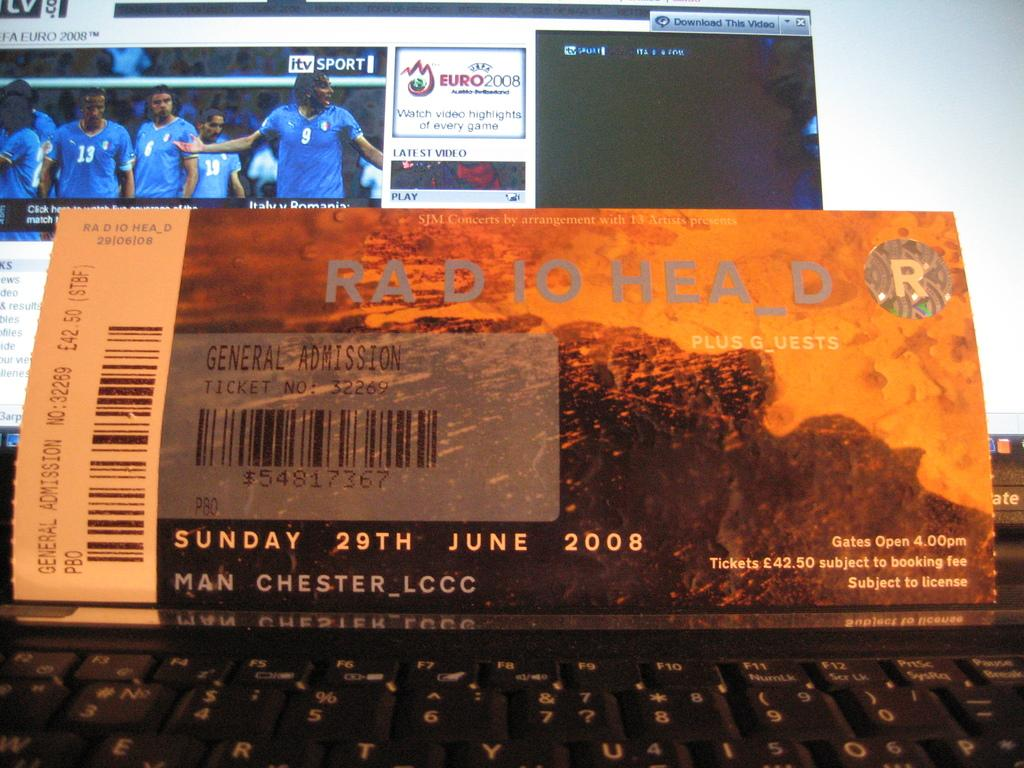<image>
Create a compact narrative representing the image presented. A ticket for a Radio Head Concert says the concert is on Sunday 29th June 2008 